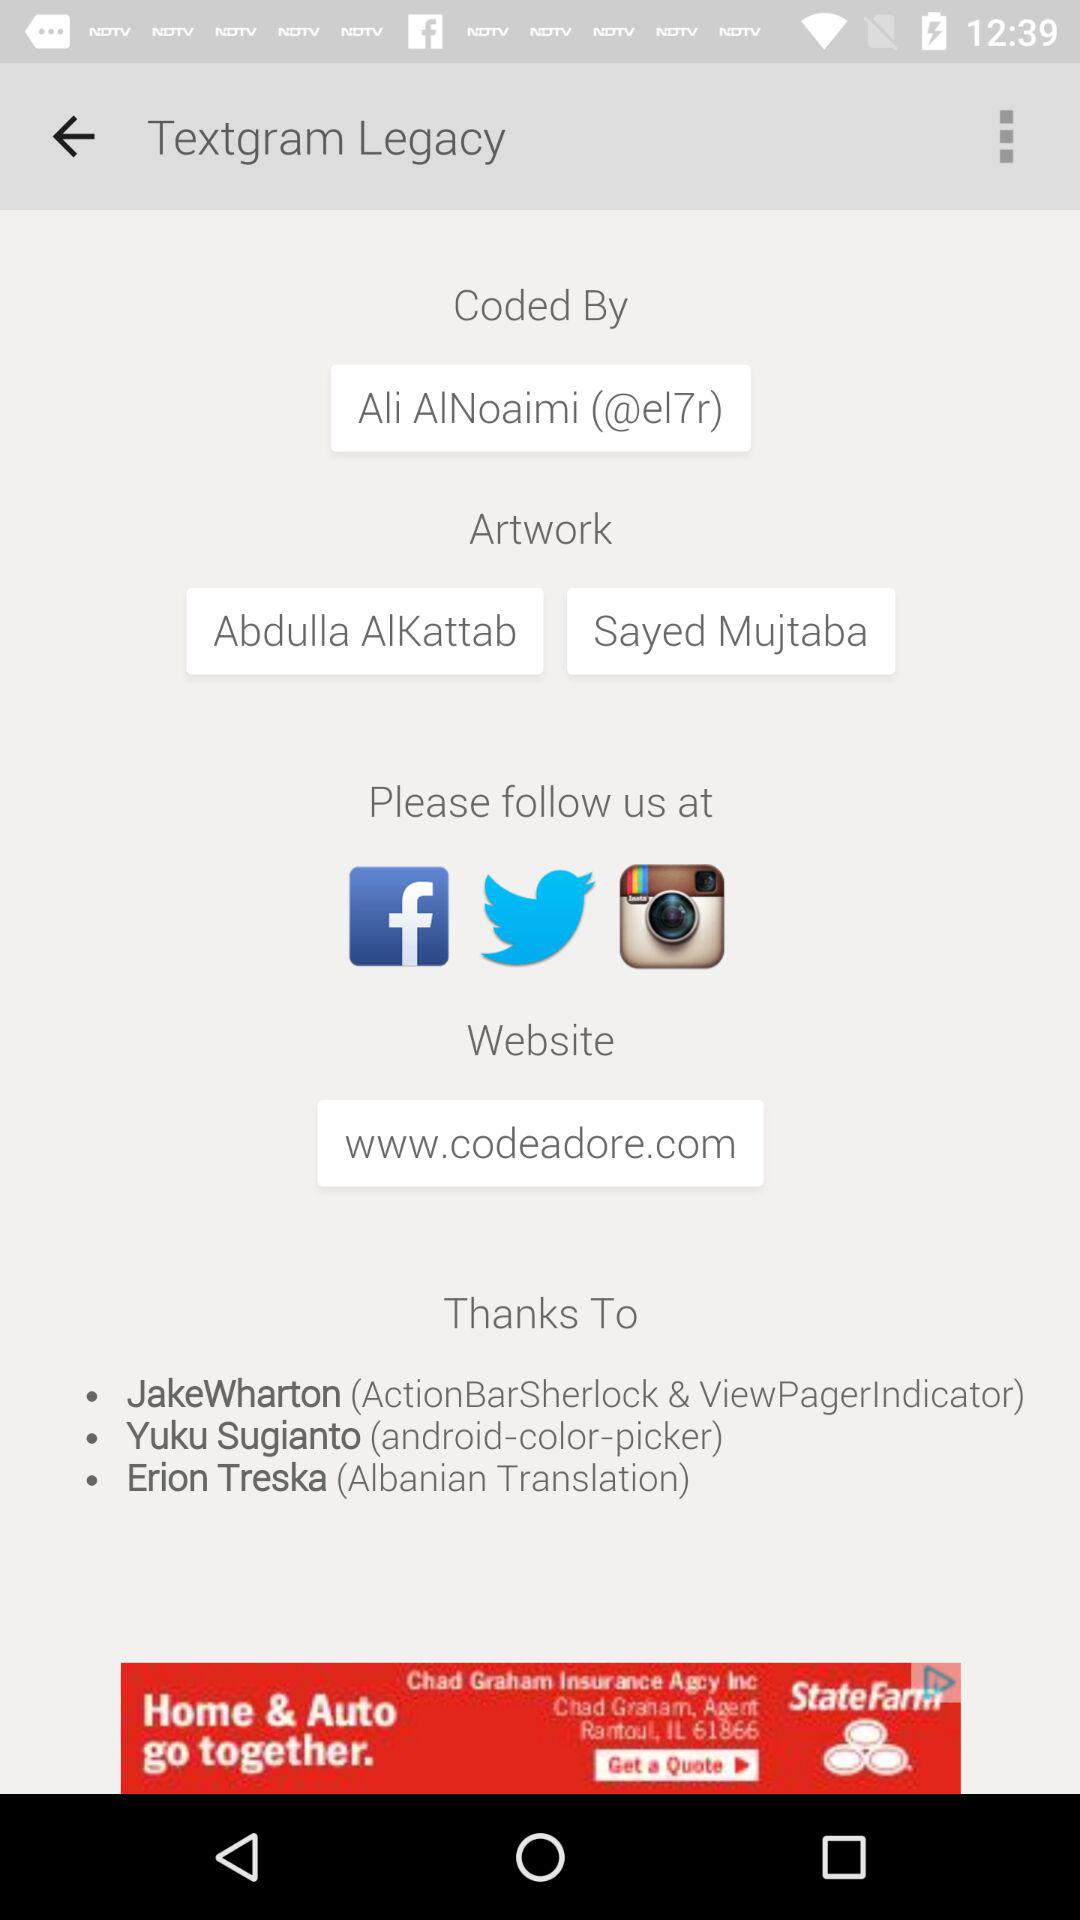By whom is "Textgram Legacy" coded? "Textgram Legacy" is coded by Ali AlNoaimi. 